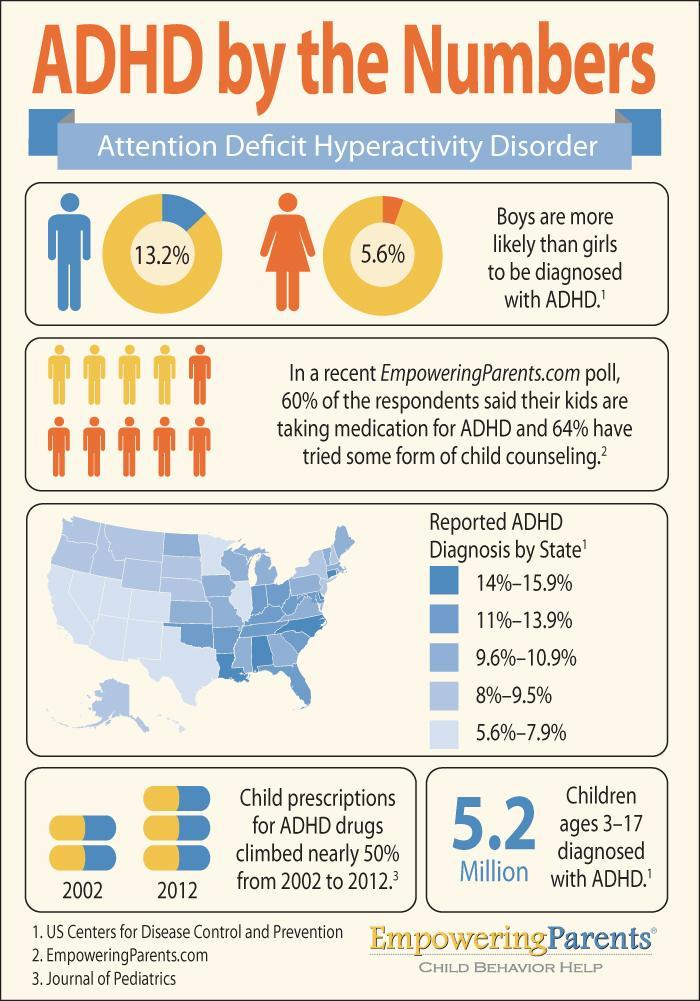What is the colour of the female icon - blue, yellow or orange?
Answer the question with a short phrase. orange How many sources are listed? 3 In which year was child prescription for ADHD lesser by almost 50%? 2002 